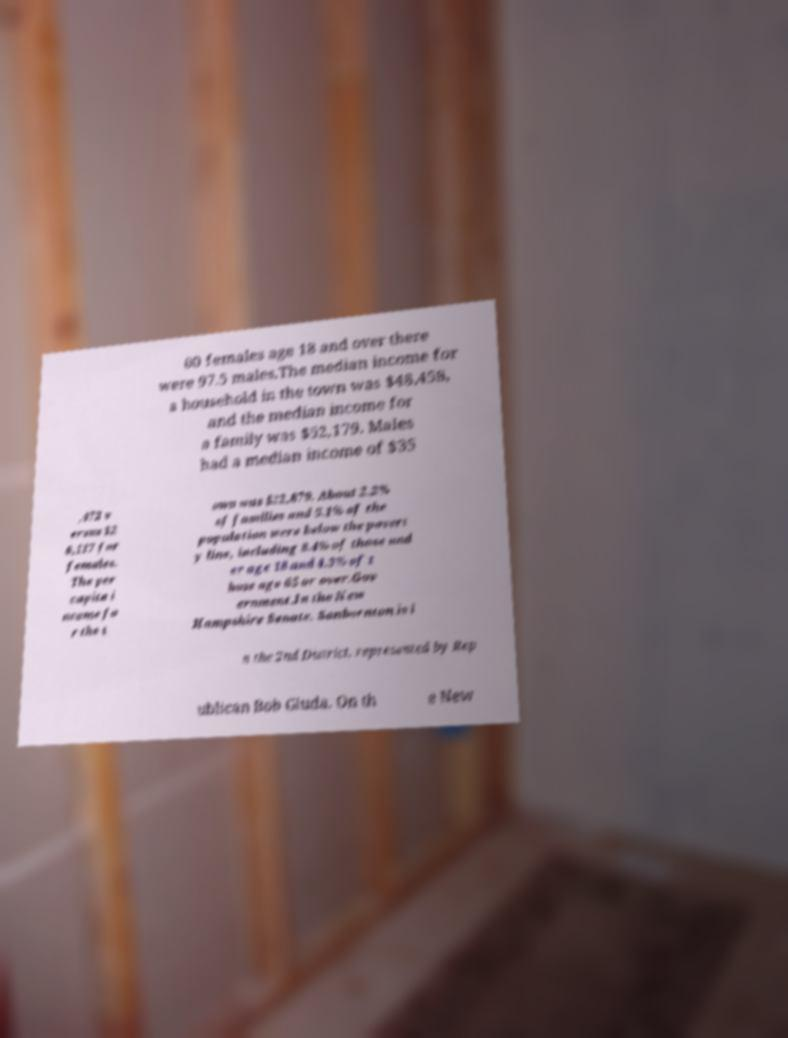Please identify and transcribe the text found in this image. 00 females age 18 and over there were 97.5 males.The median income for a household in the town was $48,458, and the median income for a family was $52,179. Males had a median income of $35 ,472 v ersus $2 6,117 for females. The per capita i ncome fo r the t own was $22,879. About 2.2% of families and 5.1% of the population were below the povert y line, including 8.4% of those und er age 18 and 4.3% of t hose age 65 or over.Gov ernment.In the New Hampshire Senate, Sanbornton is i n the 2nd District, represented by Rep ublican Bob Giuda. On th e New 